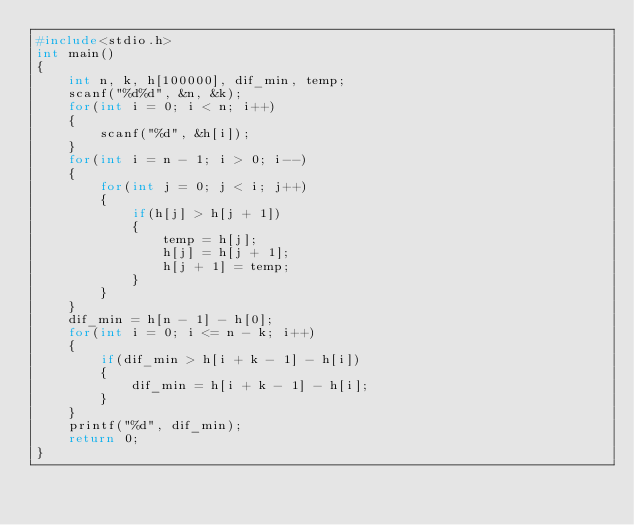Convert code to text. <code><loc_0><loc_0><loc_500><loc_500><_C++_>#include<stdio.h>
int main()
{
    int n, k, h[100000], dif_min, temp;
    scanf("%d%d", &n, &k);
    for(int i = 0; i < n; i++)
    {
        scanf("%d", &h[i]);
    }
    for(int i = n - 1; i > 0; i--)
    {
        for(int j = 0; j < i; j++)
        {
            if(h[j] > h[j + 1])
            {
                temp = h[j];
                h[j] = h[j + 1];
                h[j + 1] = temp;
            }
        }
    }
    dif_min = h[n - 1] - h[0];
    for(int i = 0; i <= n - k; i++)
    {
        if(dif_min > h[i + k - 1] - h[i])
        {
            dif_min = h[i + k - 1] - h[i];
        }
    }
    printf("%d", dif_min);
    return 0;
}
</code> 